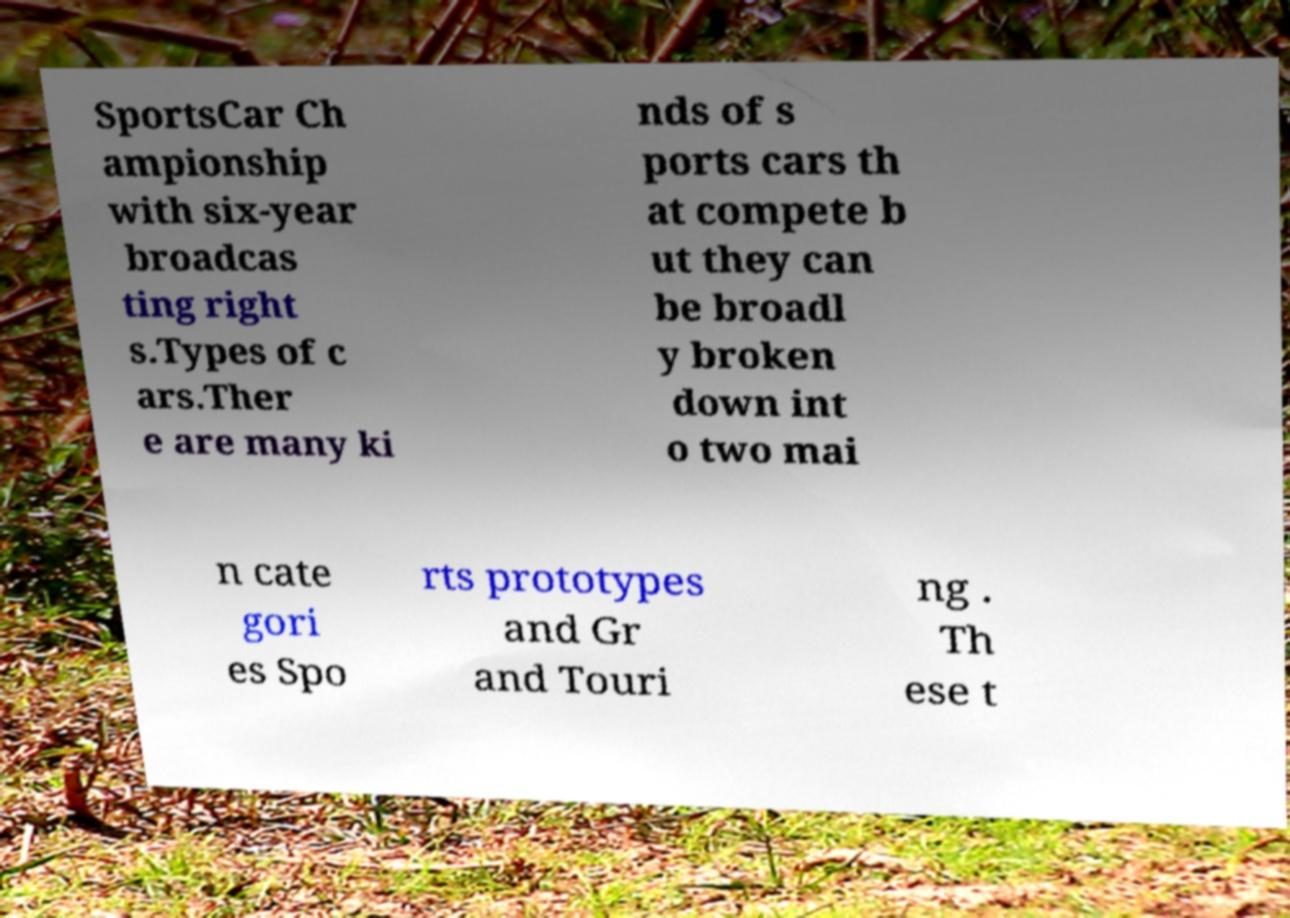Can you accurately transcribe the text from the provided image for me? SportsCar Ch ampionship with six-year broadcas ting right s.Types of c ars.Ther e are many ki nds of s ports cars th at compete b ut they can be broadl y broken down int o two mai n cate gori es Spo rts prototypes and Gr and Touri ng . Th ese t 